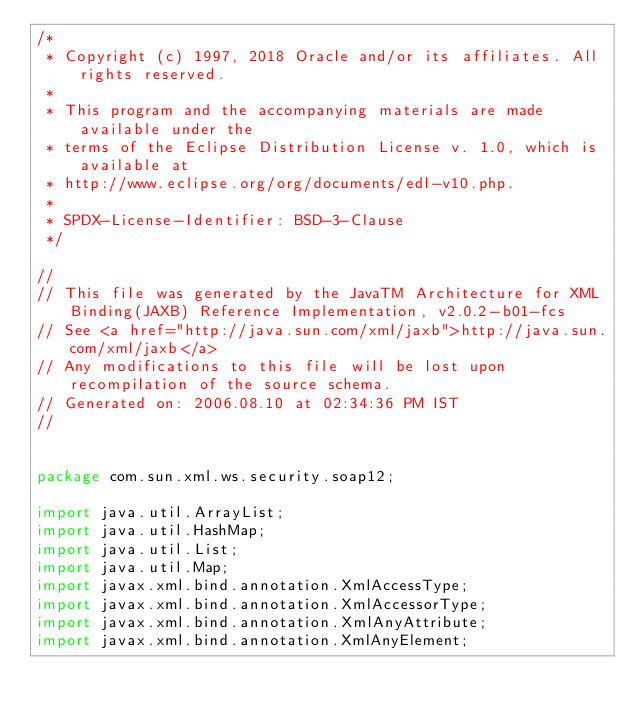<code> <loc_0><loc_0><loc_500><loc_500><_Java_>/*
 * Copyright (c) 1997, 2018 Oracle and/or its affiliates. All rights reserved.
 *
 * This program and the accompanying materials are made available under the
 * terms of the Eclipse Distribution License v. 1.0, which is available at
 * http://www.eclipse.org/org/documents/edl-v10.php.
 *
 * SPDX-License-Identifier: BSD-3-Clause
 */

//
// This file was generated by the JavaTM Architecture for XML Binding(JAXB) Reference Implementation, v2.0.2-b01-fcs 
// See <a href="http://java.sun.com/xml/jaxb">http://java.sun.com/xml/jaxb</a> 
// Any modifications to this file will be lost upon recompilation of the source schema. 
// Generated on: 2006.08.10 at 02:34:36 PM IST 
//


package com.sun.xml.ws.security.soap12;

import java.util.ArrayList;
import java.util.HashMap;
import java.util.List;
import java.util.Map;
import javax.xml.bind.annotation.XmlAccessType;
import javax.xml.bind.annotation.XmlAccessorType;
import javax.xml.bind.annotation.XmlAnyAttribute;
import javax.xml.bind.annotation.XmlAnyElement;</code> 